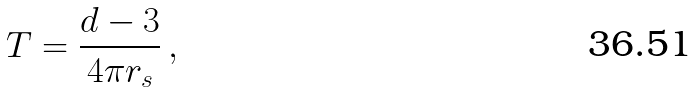<formula> <loc_0><loc_0><loc_500><loc_500>T = \frac { d - 3 } { 4 \pi r _ { s } } \, ,</formula> 